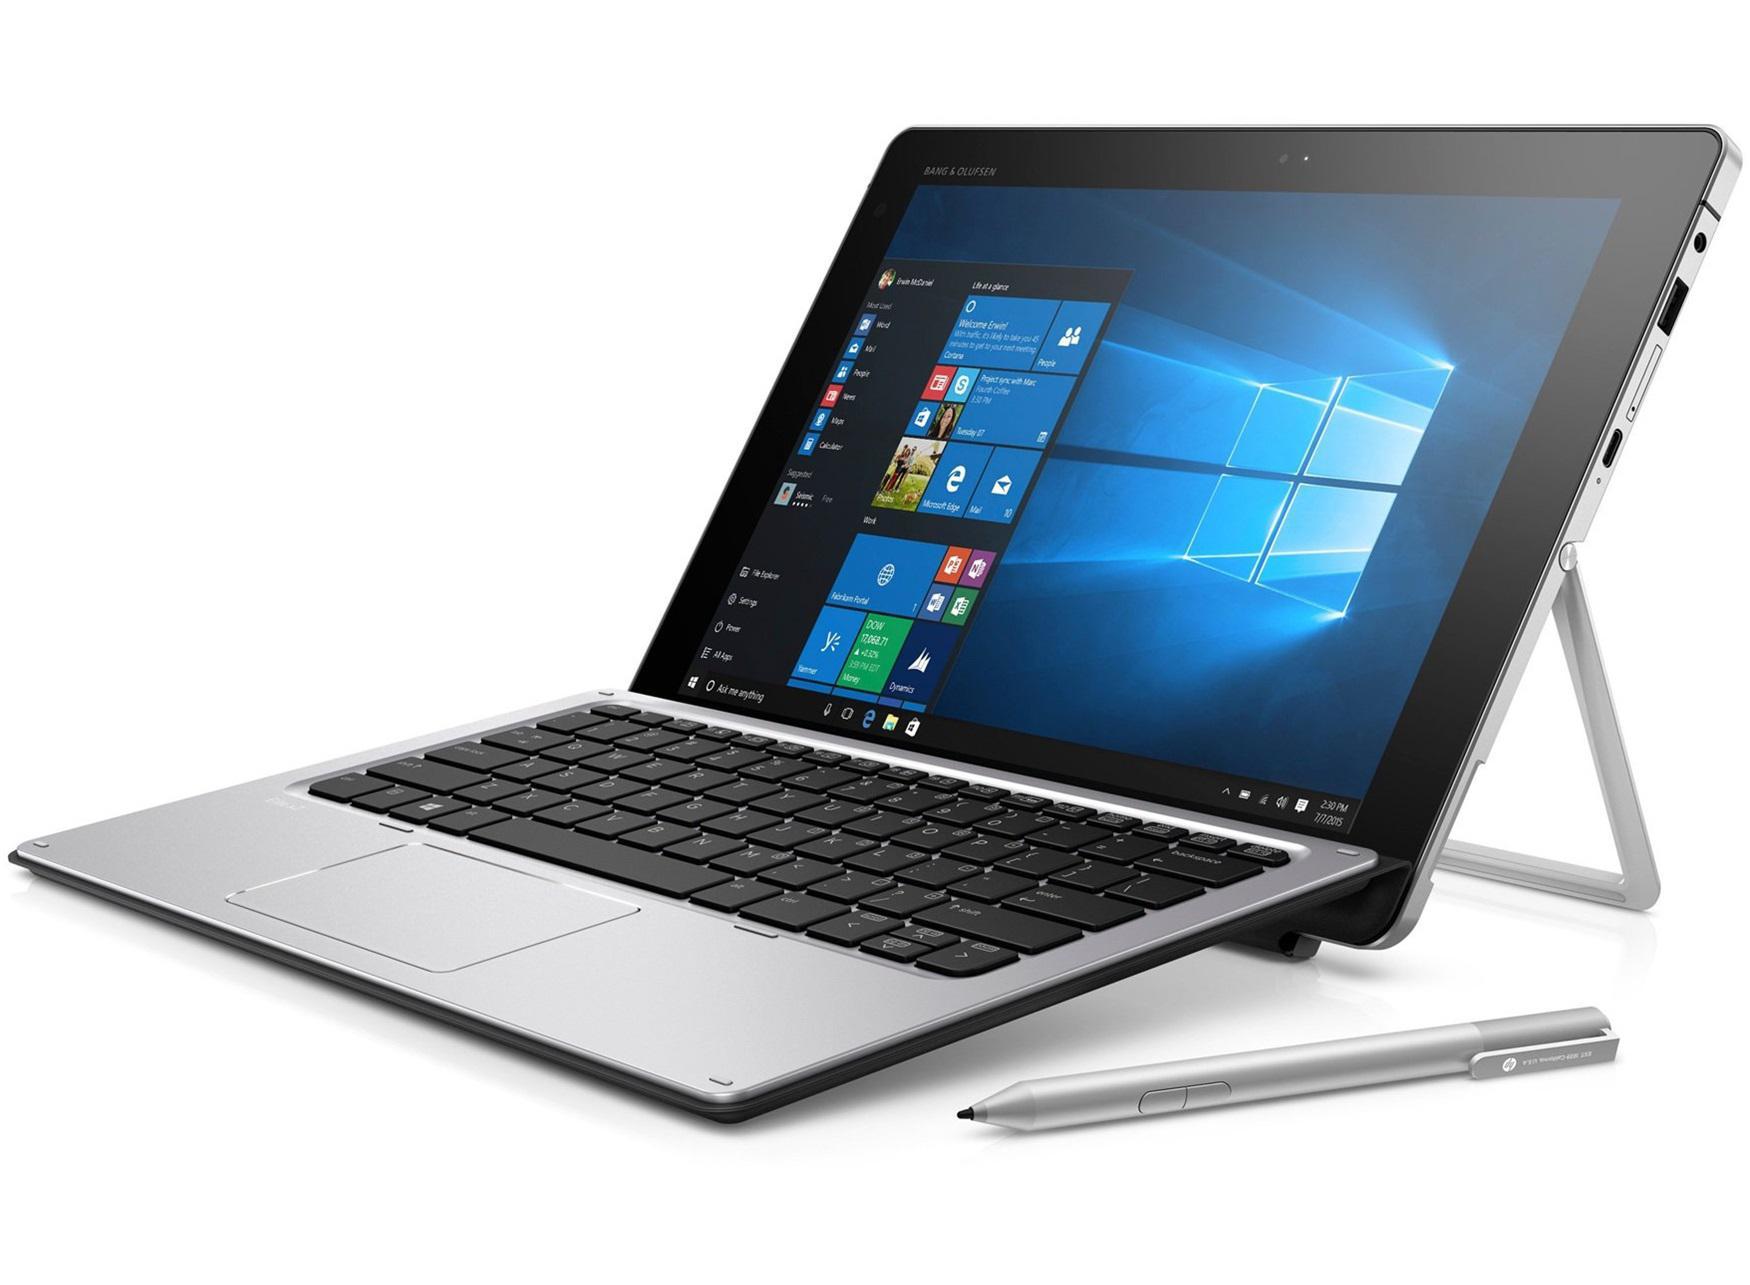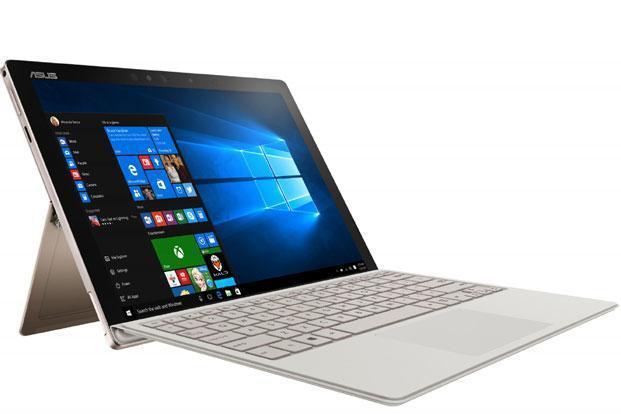The first image is the image on the left, the second image is the image on the right. For the images displayed, is the sentence "The right image contains a laptop with a kickstand propping the screen up." factually correct? Answer yes or no. Yes. 